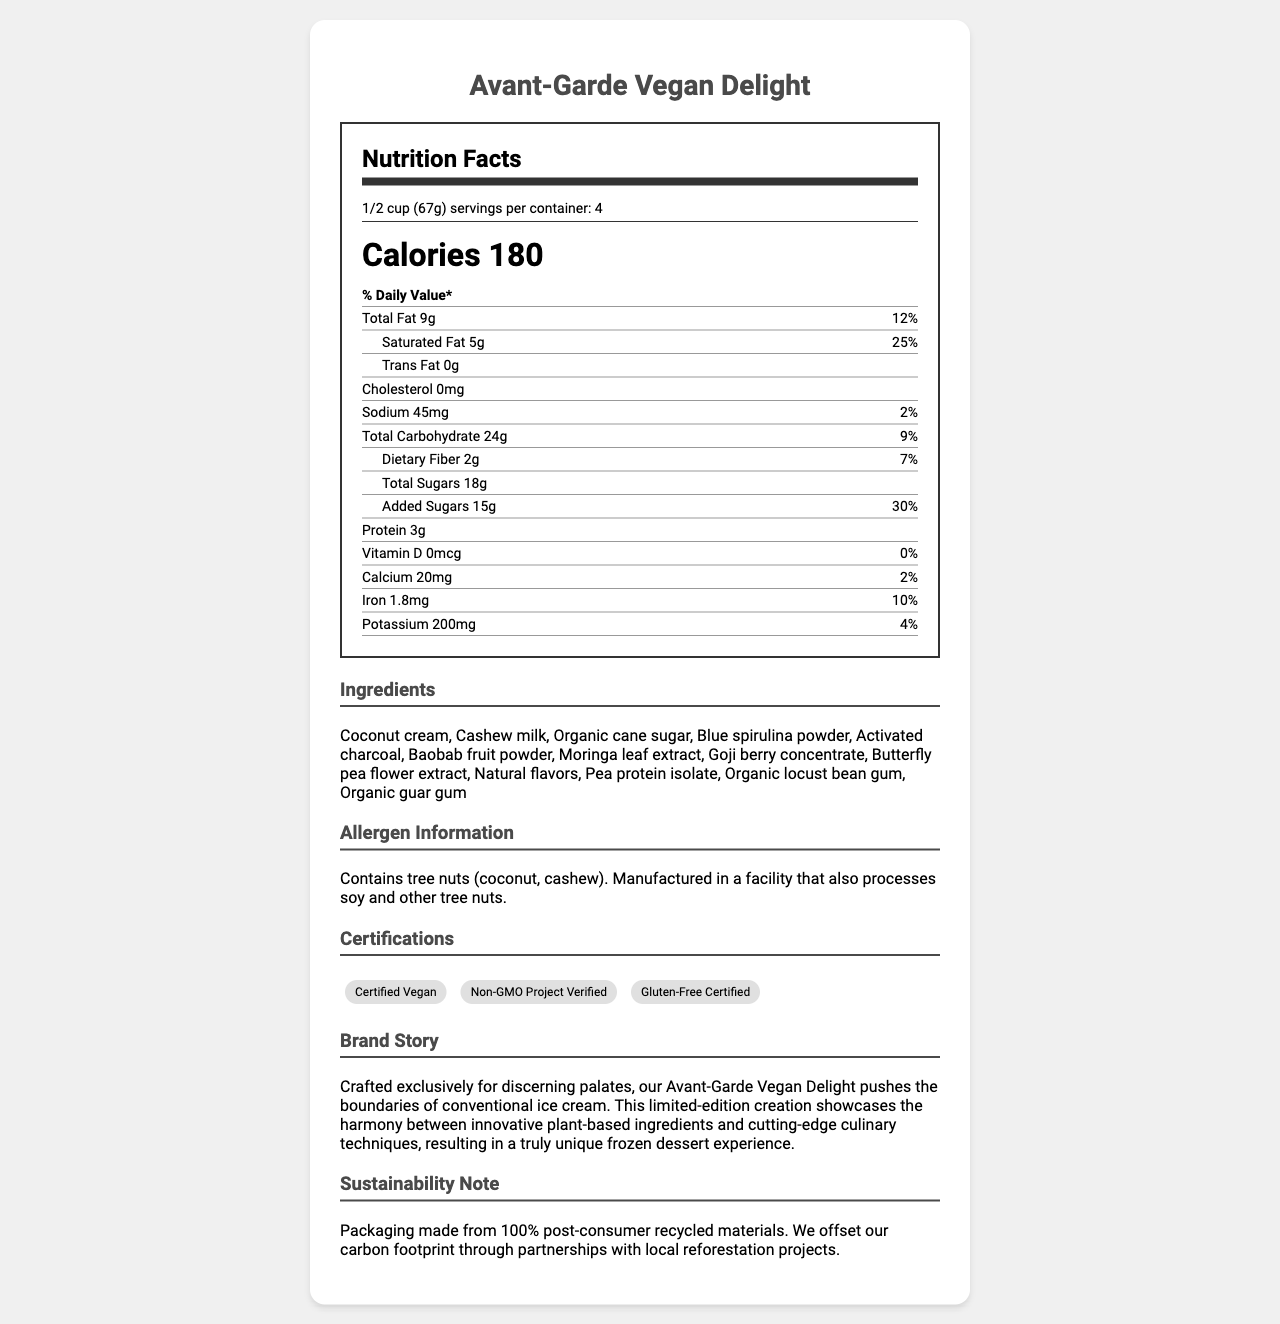what is the serving size? The serving size is explicitly listed as "1/2 cup (67g)" in the nutrition facts section.
Answer: 1/2 cup (67g) how many servings per container? The document states there are 4 servings per container.
Answer: 4 what is the amount of total fat per serving? The nutrition facts section shows that the total fat amount per serving is 9g.
Answer: 9g what percentage of the daily value for saturated fat is in one serving? For one serving, the daily value percentage for saturated fat is listed as 25%.
Answer: 25% is there any cholesterol in the product? The nutrition facts indicate that the cholesterol content is 0mg, meaning there is no cholesterol in the product.
Answer: No which ingredient is not listed? A. Blue spirulina powder B. Coconut cream C. Almond milk D. Cashew milk The ingredients listed include Blue spirulina powder, Coconut cream, and Cashew milk, but not Almond milk.
Answer: C. Almond milk what is the daily value percentage of iron per serving? A. 2% B. 4% C. 10% D. 12% The daily value percentage for iron per serving is given as 10% in the nutrition facts.
Answer: C. 10% is the ice cream certified vegan? The certifications section lists "Certified Vegan," indicating that the product is vegan.
Answer: Yes summarize the document The document is a comprehensive summary of the Avant-Garde Vegan Delight ice cream's nutritional details, ingredients, certifications, and sustainability efforts. It mentions the unique aspects of the product and its compatibility with vegan and gluten-free diets.
Answer: The document provides detailed nutritional information for the Avant-Garde Vegan Delight, including serving size, calories, fat, carbohydrates, and protein content. It also lists the unique plant-based ingredients, allergen information, certifications, and a brand story highlighting its innovative nature. Additionally, the sustainability note emphasizes eco-friendly packaging and carbon offset initiatives. which certifications does the product have? The certifications section lists these three certifications for the product.
Answer: Certified Vegan, Non-GMO Project Verified, Gluten-Free Certified can people with tree nut allergies consume this product? The allergen information states that the product contains tree nuts (coconut, cashew) and is manufactured in a facility that also processes soy and other tree nuts, so people with tree nut allergies should exercise caution.
Answer: They should be cautious what is the main ingredient used for the creamy texture? The ingredients list starts with coconut cream, indicating that it is a primary ingredient for the creamy texture.
Answer: Coconut cream are there any artificial flavors in this product? The ingredients list includes "Natural flavors," which implies the absence of artificial flavors.
Answer: No is the ice cream gluten-free? The certifications section includes "Gluten-Free Certified," confirming that the product is gluten-free.
Answer: Yes what is the daily value percentage of calcium per serving? The nutrition facts show that the daily value percentage for calcium per serving is 2%.
Answer: 2% how many grams of added sugars are in one serving? The nutrition facts state that there are 15g of added sugars in one serving.
Answer: 15g how many calories are there in one serving? The document indicates that there are 180 calories per serving.
Answer: 180 what is the total carbohydrates amount per serving? The nutrition facts list the total carbohydrate amount per serving as 24g.
Answer: 24g can the manufacturing facility also process soy? The allergen information mentions that the facility processes soy and other tree nuts.
Answer: Yes what certification is missing? A. Certified Gluten-Free B. Organic Certified C. Non-GMO Project Verified D. Certified Vegan The certifications listed do not include "Organic Certified."
Answer: B. Organic Certified what is the amount of dietary fiber per serving? The nutrition facts state that the dietary fiber amount per serving is 2g.
Answer: 2g does the product contain any activated charcoal? The ingredients list includes activated charcoal as one of the ingredients.
Answer: Yes what are the unconventional ingredients in this product? These ingredients are listed in the ingredients section and are considered unconventional for ice cream.
Answer: Blue spirulina powder, Activated charcoal, Baobab fruit powder, Moringa leaf extract, Goji berry concentrate, Butterfly pea flower extract who is the target audience for this ice cream? The brand story highlights that the product is crafted exclusively for discerning palates and emphasizes the unique and innovative nature of the ice cream.
Answer: Discerning palates looking for innovative and unique frozen dessert experiences what is the recommended daily value percentage of sodium in one serving? The nutrition facts show that the daily value percentage of sodium in one serving is 2%.
Answer: 2% what information is missing regarding the manufacturing facility? The document does not mention specific details about the location or other manufacturing practices, other than the allergen information related to processing soy and other tree nuts.
Answer: Cannot be determined 